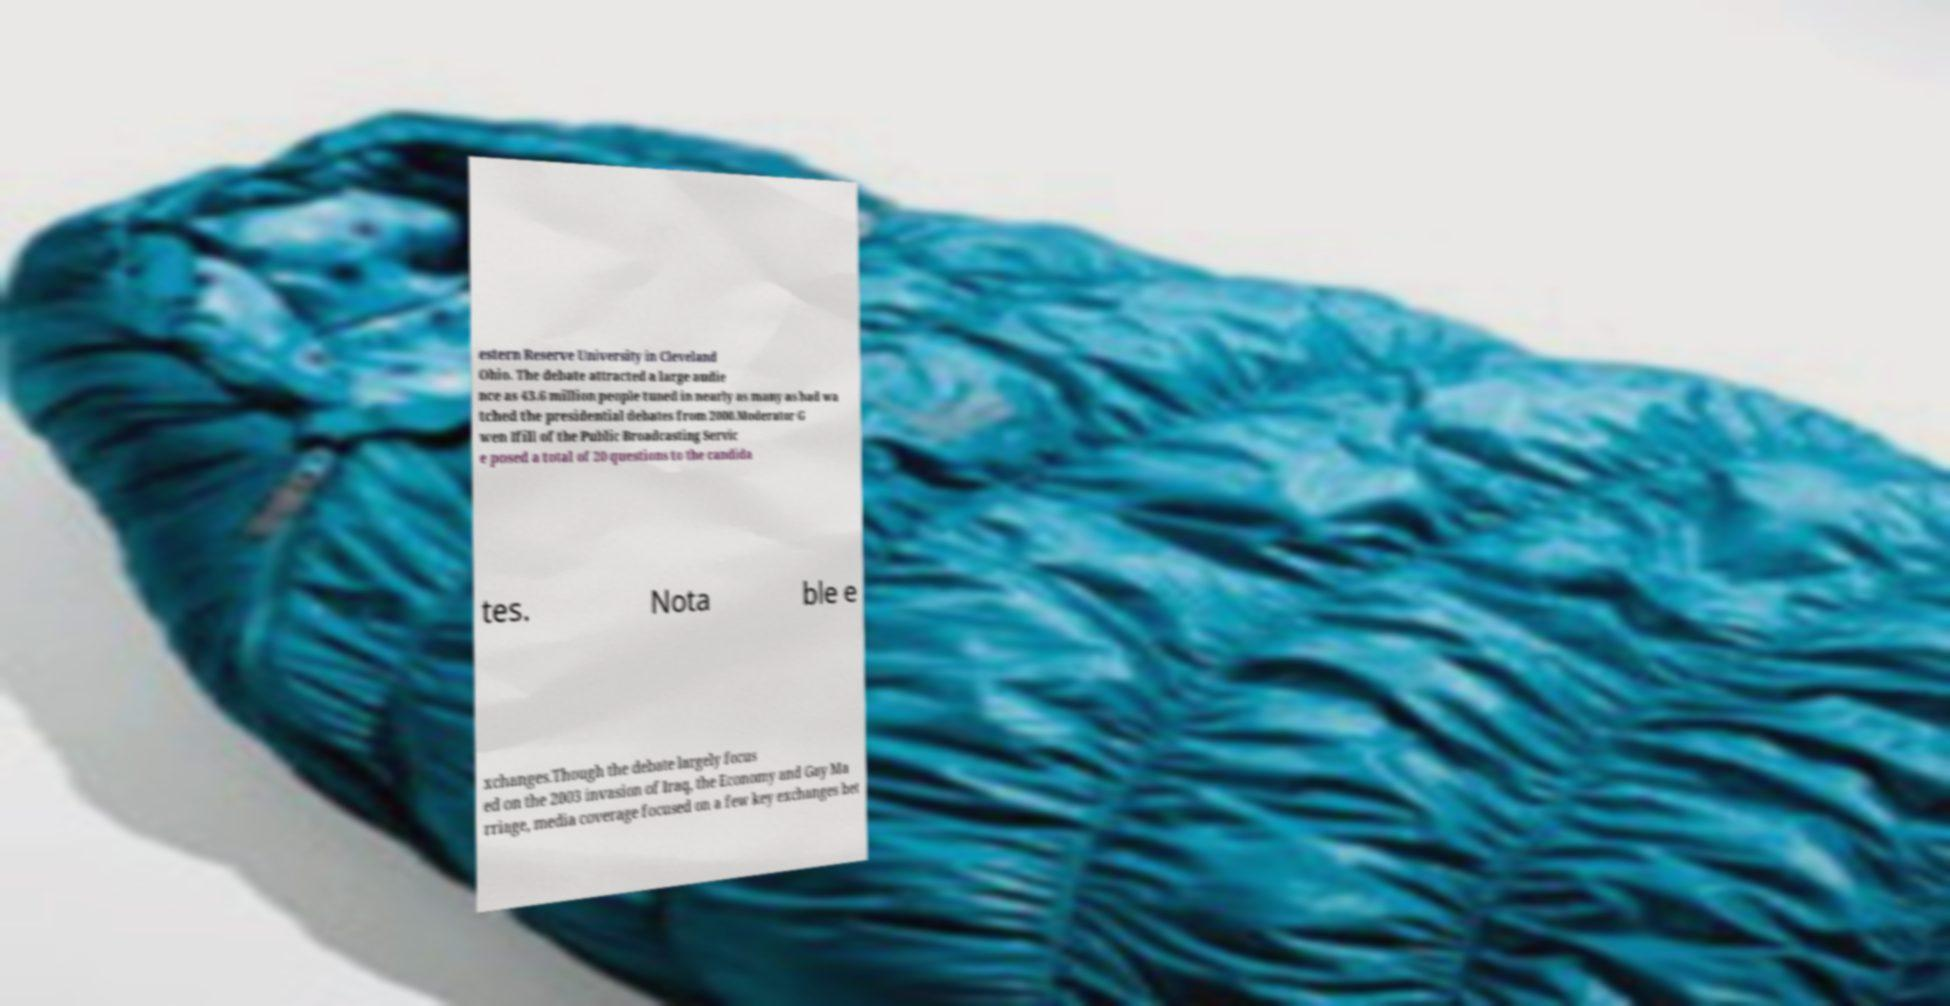Please read and relay the text visible in this image. What does it say? estern Reserve University in Cleveland Ohio. The debate attracted a large audie nce as 43.6 million people tuned in nearly as many as had wa tched the presidential debates from 2000.Moderator G wen Ifill of the Public Broadcasting Servic e posed a total of 20 questions to the candida tes. Nota ble e xchanges.Though the debate largely focus ed on the 2003 invasion of Iraq, the Economy and Gay Ma rriage, media coverage focused on a few key exchanges bet 